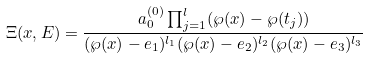Convert formula to latex. <formula><loc_0><loc_0><loc_500><loc_500>\Xi ( x , E ) = \frac { a _ { 0 } ^ { ( 0 ) } \prod _ { j = 1 } ^ { l } ( \wp ( x ) - \wp ( t _ { j } ) ) } { ( \wp ( x ) - e _ { 1 } ) ^ { l _ { 1 } } ( \wp ( x ) - e _ { 2 } ) ^ { l _ { 2 } } ( \wp ( x ) - e _ { 3 } ) ^ { l _ { 3 } } }</formula> 